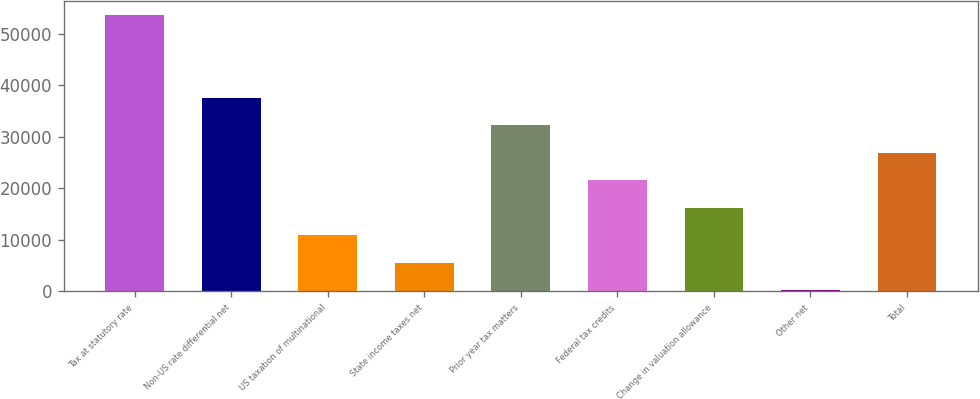<chart> <loc_0><loc_0><loc_500><loc_500><bar_chart><fcel>Tax at statutory rate<fcel>Non-US rate differential net<fcel>US taxation of multinational<fcel>State income taxes net<fcel>Prior year tax matters<fcel>Federal tax credits<fcel>Change in valuation allowance<fcel>Other net<fcel>Total<nl><fcel>53663<fcel>37645.1<fcel>10948.6<fcel>5609.3<fcel>32305.8<fcel>21627.2<fcel>16287.9<fcel>270<fcel>26966.5<nl></chart> 